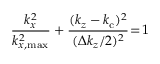Convert formula to latex. <formula><loc_0><loc_0><loc_500><loc_500>\frac { k _ { x } ^ { 2 } } { k _ { x , \max } ^ { 2 } } + \frac { ( k _ { z } - k _ { c } ) ^ { 2 } } { ( \Delta k _ { z } / 2 ) ^ { 2 } } \, = \, 1</formula> 